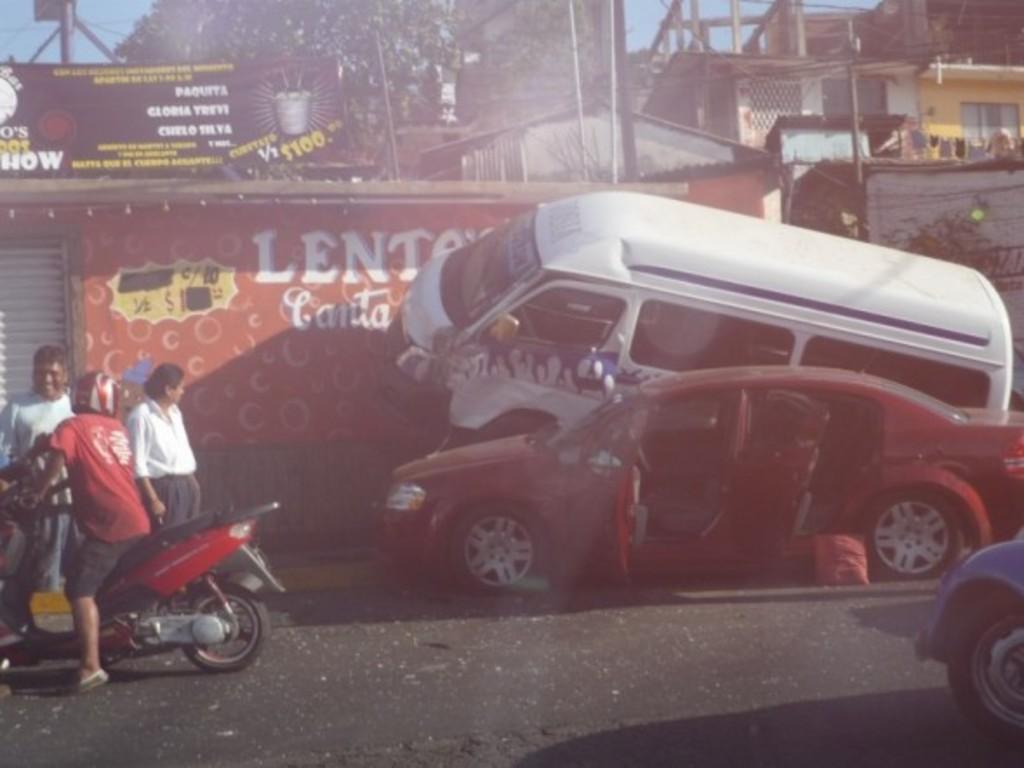Describe this image in one or two sentences. In this picture outside of the city. Both cars are damaged on a road. On the left side we have a three persons. They are standing. The red color shirt person wearing a helmet. We can see in background trees,banner,house and sky. 